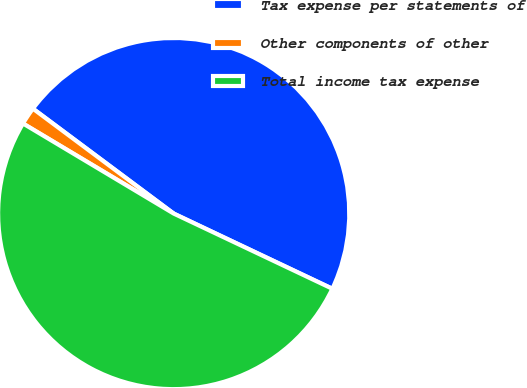<chart> <loc_0><loc_0><loc_500><loc_500><pie_chart><fcel>Tax expense per statements of<fcel>Other components of other<fcel>Total income tax expense<nl><fcel>46.85%<fcel>1.62%<fcel>51.53%<nl></chart> 